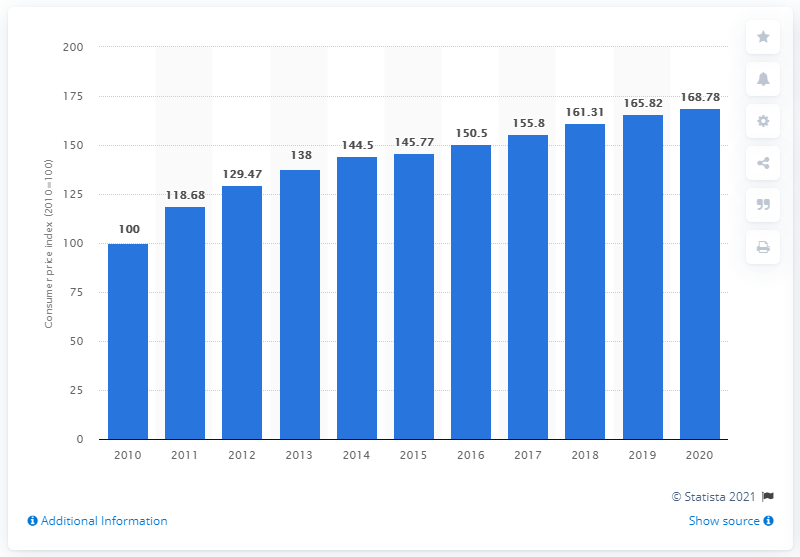Give some essential details in this illustration. The base year for the consumer price index in Vietnam was 2010. In 2020, the consumer price index for all items in Vietnam was 168.78 points. 